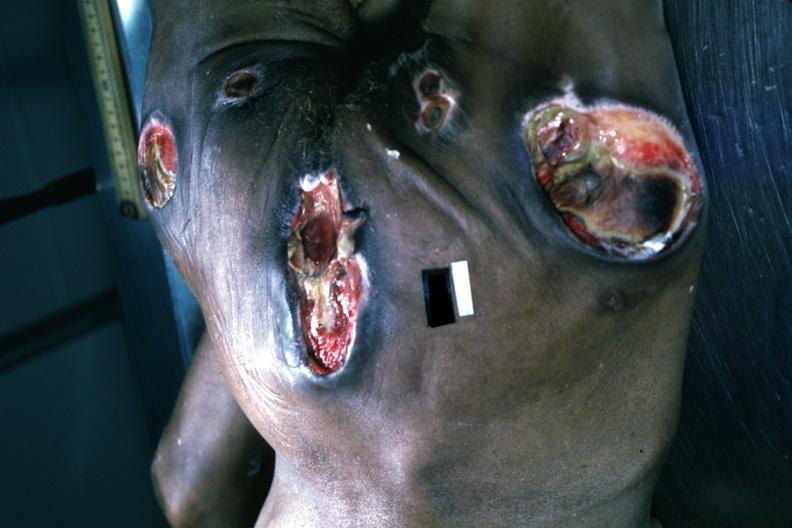s decubitus ulcer present?
Answer the question using a single word or phrase. Yes 